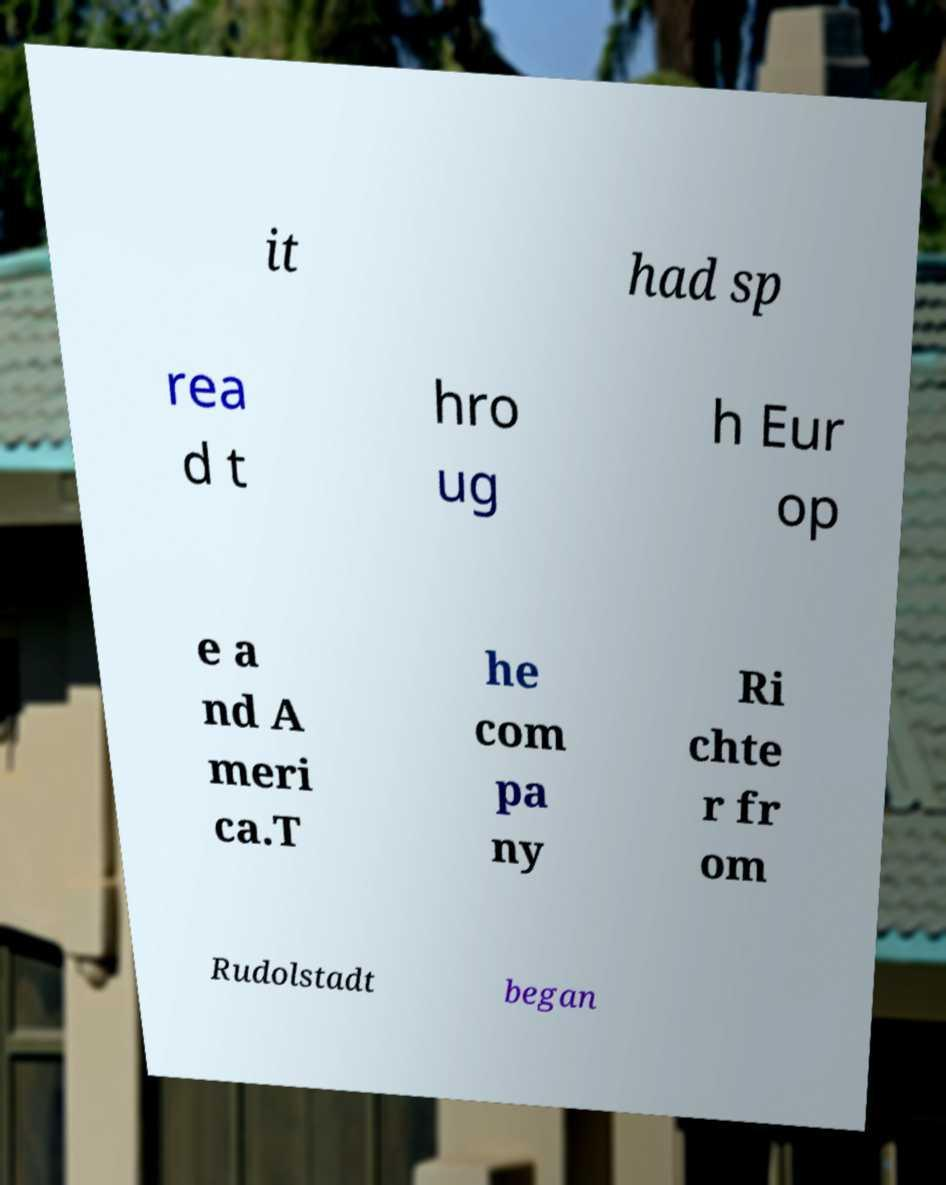I need the written content from this picture converted into text. Can you do that? it had sp rea d t hro ug h Eur op e a nd A meri ca.T he com pa ny Ri chte r fr om Rudolstadt began 